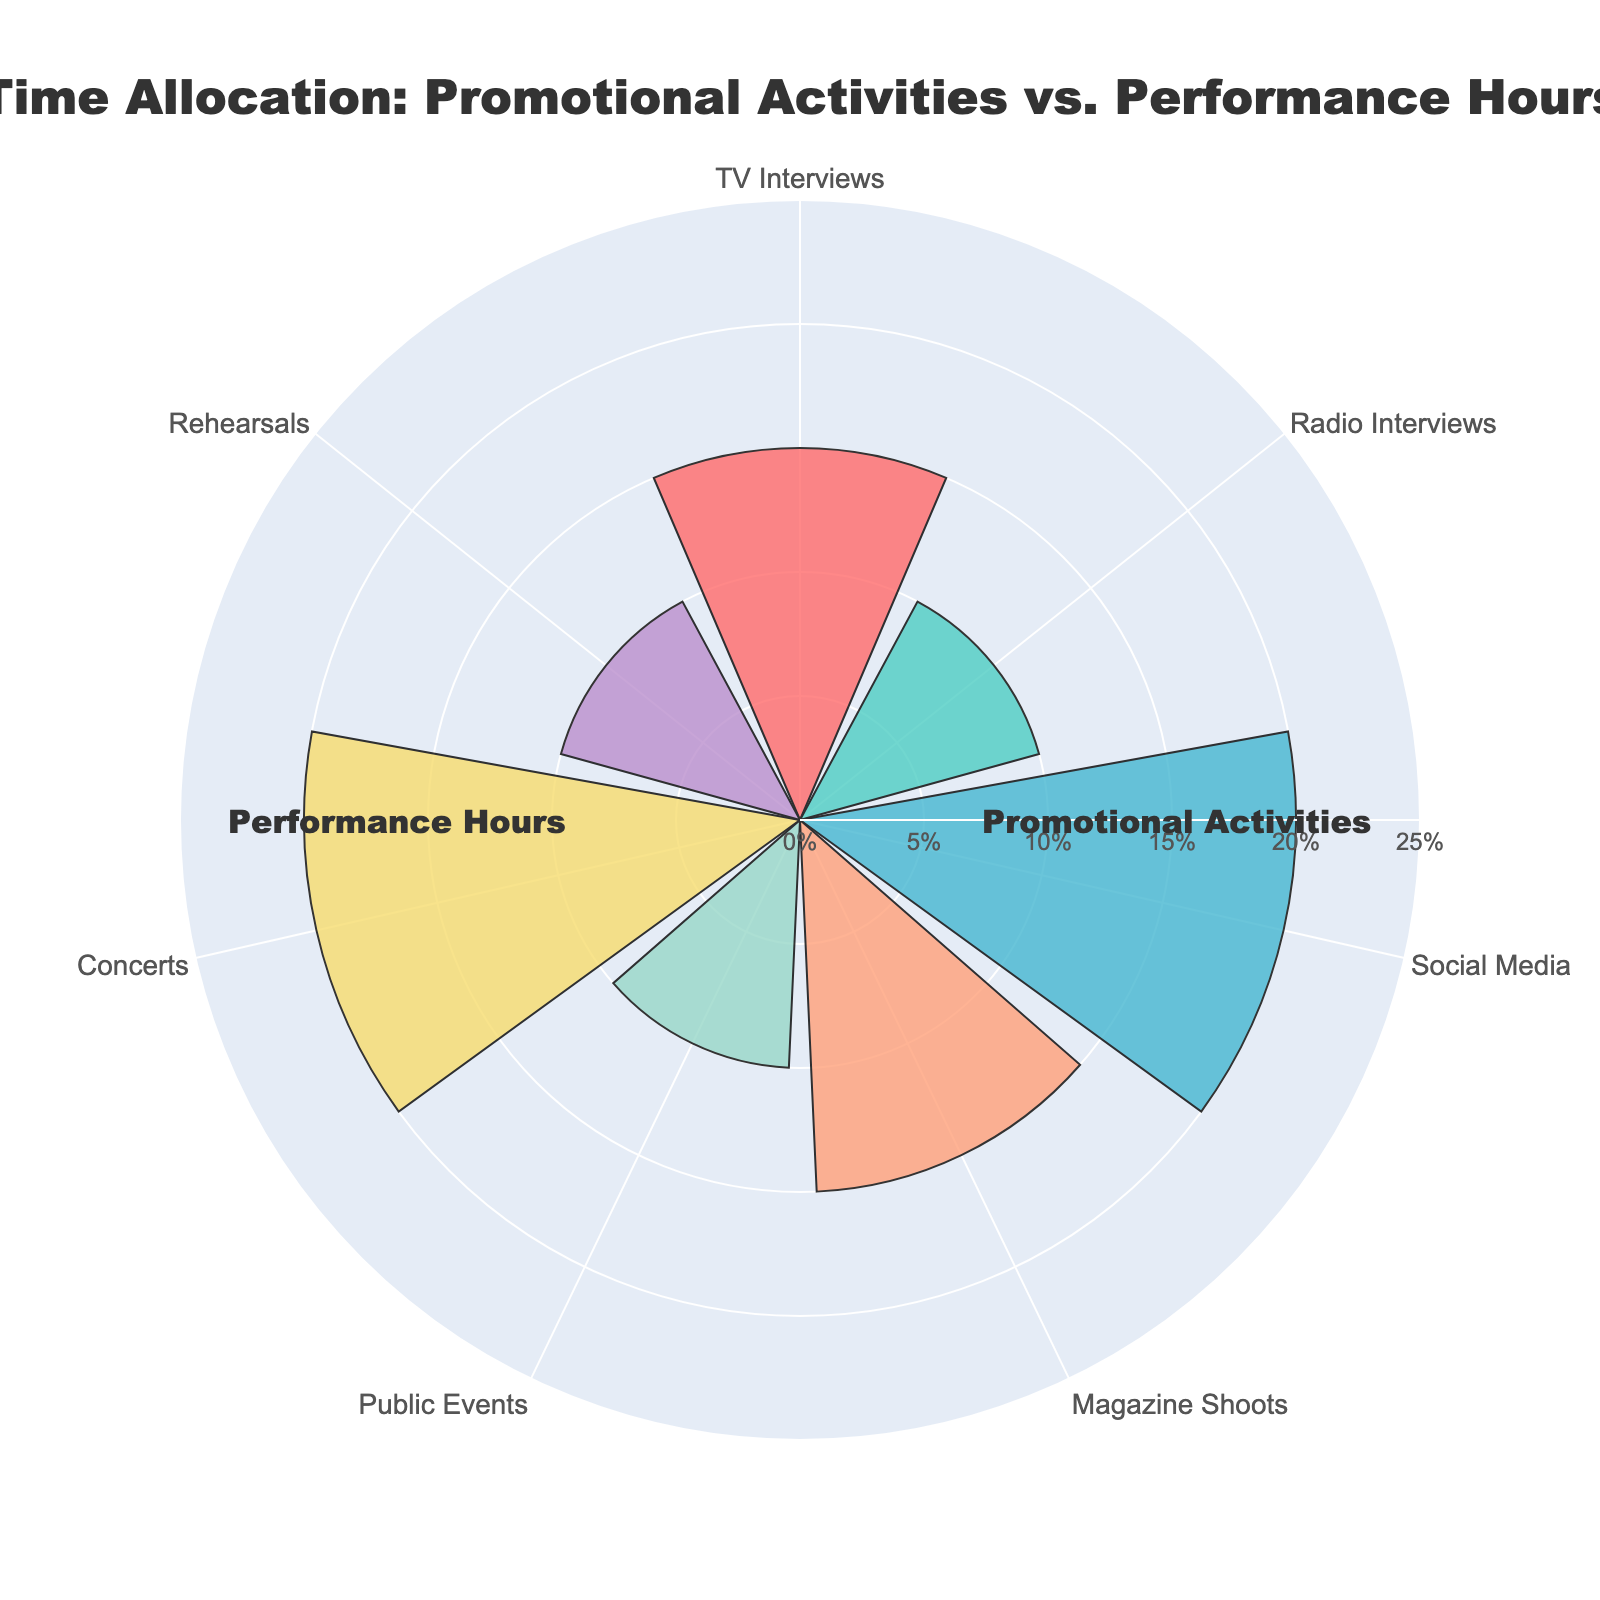What's the title of the chart? The title is placed at the top of the chart and is generally larger in font size compared to other text elements. It provides the main subject or the theme of the plot.
Answer: Time Allocation: Promotional Activities vs. Performance Hours How many categories of activities are presented in the chart? By looking at the different segments of activities listed around the rose chart, we can identify the distinct categories of activities being compared.
Answer: 2 (Promotional Activities and Performance Hours) Which activity within Promotional Activities occupies the largest percentage? To find the activity occupying the largest percentage within Promotional Activities, we look for the largest segment among TV Interviews, Radio Interviews, Social Media, Magazine Shoots, and Public Events.
Answer: Social Media What's the combined percentage of TV Interviews and Rehearsals? Add the percentage of TV Interviews and Rehearsals: TV Interviews is 15% and Rehearsals is 10%. Therefore, 15 + 10 = 25.
Answer: 25% How does the percentage of Public Events compare to Radio Interviews? Compare the segments for Public Events and Radio Interviews by examining their sizes or the given percentages. Public Events has a percentage of 10%, and Radio Interviews also has 10%. Thus, they are equal.
Answer: They are equal Which category has more overall percentage, Promotional Activities or Performance Hours? Sum the percentages for each category separately and compare the totals. Promotional Activities: 15 + 10 + 20 + 15 + 10 = 70%. Performance Hours: 20 + 10 = 30%.
Answer: Promotional Activities How do Concerts compare to Magazine Shoots in terms of percentage? Concerts occupy 20% of the total, while Magazine Shoots occupy 15%. By comparing the two numbers, Concerts have a higher percentage.
Answer: Concerts have more What's the average percentage allocation across all the activities? Add up all the percentages (15 + 10 + 20 + 15 + 10 + 20 + 10) and divide by the number of activities (7). The total is 100%, and the average is 100 / 7 = 14.29%.
Answer: 14.29% Which three activities combined make up half of the total time allocation? Identify the three activities with the highest percentages and add them: Social Media (20%), Concerts (20%), and TV Interviews (15%). Together, these make 55%, which is more than half. Checking lower combinations would result in lower than 50%.
Answer: Social Media, Concerts, TV Interviews 